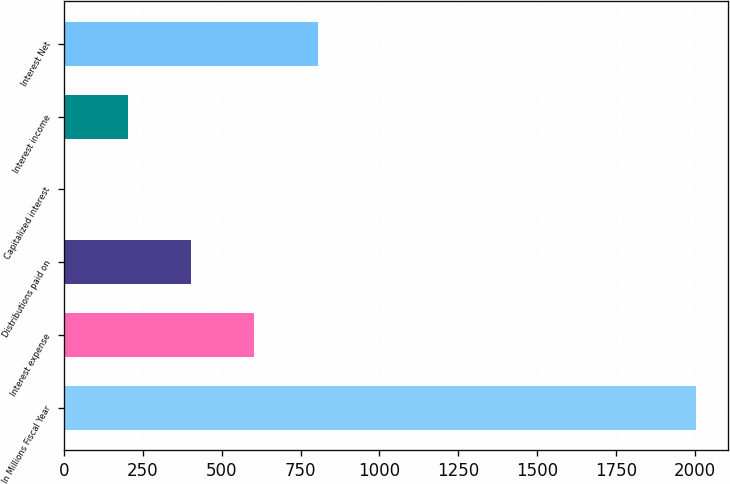Convert chart. <chart><loc_0><loc_0><loc_500><loc_500><bar_chart><fcel>In Millions Fiscal Year<fcel>Interest expense<fcel>Distributions paid on<fcel>Capitalized interest<fcel>Interest income<fcel>Interest Net<nl><fcel>2005<fcel>603.6<fcel>403.4<fcel>3<fcel>203.2<fcel>803.8<nl></chart> 